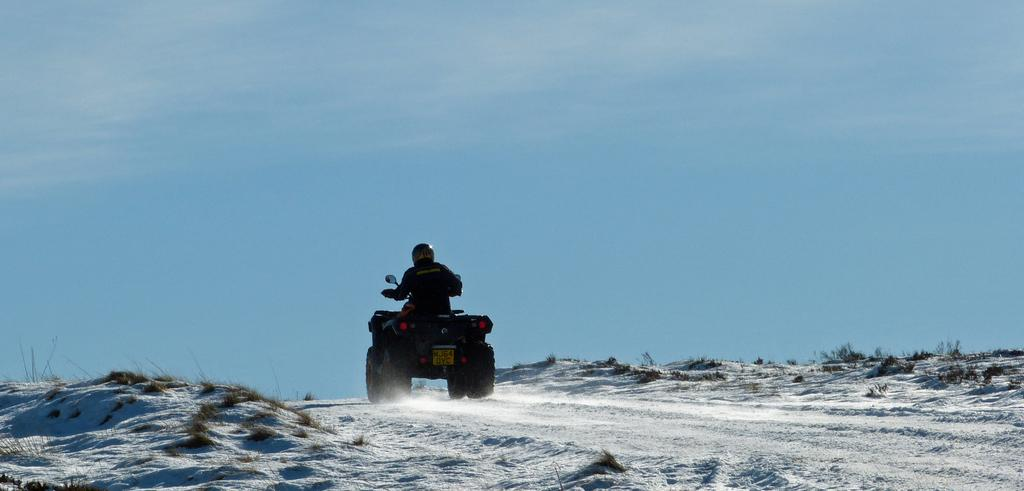What is the person doing in the image? The person is on a vehicle in the image. What type of terrain can be seen in the image? There is grass visible in the image. What is visible in the sky in the background of the image? There are clouds in the sky in the background of the image. How many lizards are crawling through the quicksand in the image? There are no lizards or quicksand present in the image. 